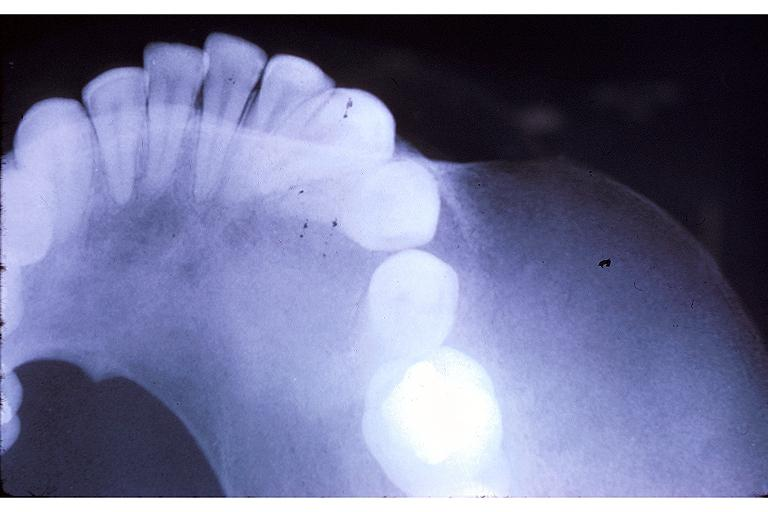does this image show fibrous dysplasia?
Answer the question using a single word or phrase. Yes 